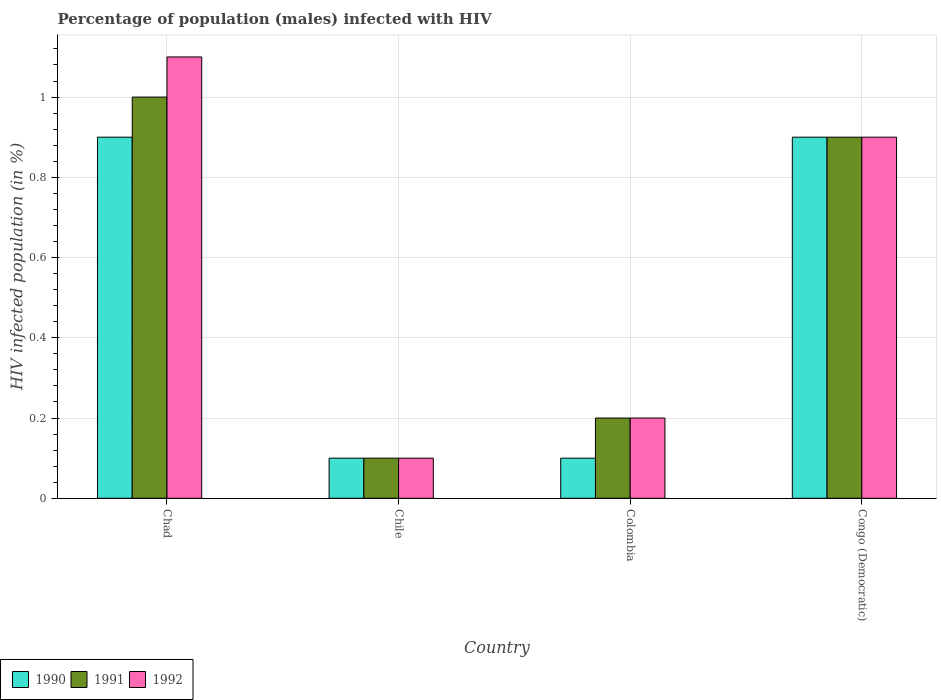What is the label of the 4th group of bars from the left?
Your answer should be very brief. Congo (Democratic). In how many cases, is the number of bars for a given country not equal to the number of legend labels?
Ensure brevity in your answer.  0. What is the percentage of HIV infected male population in 1992 in Chad?
Provide a short and direct response. 1.1. Across all countries, what is the minimum percentage of HIV infected male population in 1992?
Give a very brief answer. 0.1. In which country was the percentage of HIV infected male population in 1990 maximum?
Keep it short and to the point. Chad. What is the total percentage of HIV infected male population in 1990 in the graph?
Give a very brief answer. 2. What is the difference between the percentage of HIV infected male population in 1991 in Chad and that in Congo (Democratic)?
Your response must be concise. 0.1. What is the difference between the percentage of HIV infected male population in 1992 in Colombia and the percentage of HIV infected male population in 1991 in Chile?
Make the answer very short. 0.1. What is the average percentage of HIV infected male population in 1992 per country?
Give a very brief answer. 0.58. What is the ratio of the percentage of HIV infected male population in 1990 in Colombia to that in Congo (Democratic)?
Offer a very short reply. 0.11. What is the difference between the highest and the second highest percentage of HIV infected male population in 1992?
Offer a very short reply. -0.2. What does the 2nd bar from the left in Congo (Democratic) represents?
Offer a terse response. 1991. What does the 2nd bar from the right in Congo (Democratic) represents?
Offer a very short reply. 1991. How many bars are there?
Provide a short and direct response. 12. How many countries are there in the graph?
Provide a short and direct response. 4. Does the graph contain grids?
Your answer should be compact. Yes. How many legend labels are there?
Give a very brief answer. 3. What is the title of the graph?
Your answer should be very brief. Percentage of population (males) infected with HIV. Does "2000" appear as one of the legend labels in the graph?
Your answer should be compact. No. What is the label or title of the Y-axis?
Offer a very short reply. HIV infected population (in %). What is the HIV infected population (in %) of 1990 in Chad?
Give a very brief answer. 0.9. What is the HIV infected population (in %) in 1991 in Chad?
Keep it short and to the point. 1. What is the HIV infected population (in %) of 1992 in Chad?
Keep it short and to the point. 1.1. What is the HIV infected population (in %) of 1991 in Chile?
Provide a succinct answer. 0.1. What is the HIV infected population (in %) in 1991 in Colombia?
Provide a short and direct response. 0.2. What is the HIV infected population (in %) of 1990 in Congo (Democratic)?
Your answer should be very brief. 0.9. What is the HIV infected population (in %) of 1992 in Congo (Democratic)?
Offer a terse response. 0.9. Across all countries, what is the maximum HIV infected population (in %) in 1990?
Ensure brevity in your answer.  0.9. Across all countries, what is the maximum HIV infected population (in %) of 1991?
Provide a short and direct response. 1. Across all countries, what is the maximum HIV infected population (in %) of 1992?
Offer a very short reply. 1.1. Across all countries, what is the minimum HIV infected population (in %) of 1990?
Your answer should be very brief. 0.1. Across all countries, what is the minimum HIV infected population (in %) in 1991?
Your answer should be compact. 0.1. Across all countries, what is the minimum HIV infected population (in %) in 1992?
Ensure brevity in your answer.  0.1. What is the total HIV infected population (in %) of 1990 in the graph?
Ensure brevity in your answer.  2. What is the total HIV infected population (in %) in 1991 in the graph?
Offer a very short reply. 2.2. What is the total HIV infected population (in %) of 1992 in the graph?
Your answer should be very brief. 2.3. What is the difference between the HIV infected population (in %) in 1991 in Chad and that in Chile?
Offer a very short reply. 0.9. What is the difference between the HIV infected population (in %) of 1992 in Chad and that in Chile?
Ensure brevity in your answer.  1. What is the difference between the HIV infected population (in %) of 1990 in Chad and that in Colombia?
Give a very brief answer. 0.8. What is the difference between the HIV infected population (in %) in 1991 in Chad and that in Colombia?
Your response must be concise. 0.8. What is the difference between the HIV infected population (in %) of 1992 in Chad and that in Colombia?
Make the answer very short. 0.9. What is the difference between the HIV infected population (in %) in 1991 in Chad and that in Congo (Democratic)?
Ensure brevity in your answer.  0.1. What is the difference between the HIV infected population (in %) of 1992 in Chad and that in Congo (Democratic)?
Offer a terse response. 0.2. What is the difference between the HIV infected population (in %) in 1990 in Chile and that in Colombia?
Give a very brief answer. 0. What is the difference between the HIV infected population (in %) in 1991 in Chile and that in Colombia?
Provide a succinct answer. -0.1. What is the difference between the HIV infected population (in %) in 1990 in Chile and that in Congo (Democratic)?
Offer a terse response. -0.8. What is the difference between the HIV infected population (in %) in 1991 in Chile and that in Congo (Democratic)?
Your response must be concise. -0.8. What is the difference between the HIV infected population (in %) in 1990 in Chad and the HIV infected population (in %) in 1991 in Chile?
Your answer should be compact. 0.8. What is the difference between the HIV infected population (in %) of 1990 in Chad and the HIV infected population (in %) of 1992 in Chile?
Keep it short and to the point. 0.8. What is the difference between the HIV infected population (in %) of 1991 in Chad and the HIV infected population (in %) of 1992 in Chile?
Offer a terse response. 0.9. What is the difference between the HIV infected population (in %) of 1990 in Chad and the HIV infected population (in %) of 1991 in Colombia?
Offer a very short reply. 0.7. What is the difference between the HIV infected population (in %) of 1991 in Chad and the HIV infected population (in %) of 1992 in Colombia?
Your answer should be very brief. 0.8. What is the difference between the HIV infected population (in %) of 1991 in Chad and the HIV infected population (in %) of 1992 in Congo (Democratic)?
Your response must be concise. 0.1. What is the difference between the HIV infected population (in %) in 1990 in Chile and the HIV infected population (in %) in 1991 in Colombia?
Provide a short and direct response. -0.1. What is the difference between the HIV infected population (in %) in 1990 in Chile and the HIV infected population (in %) in 1992 in Congo (Democratic)?
Your answer should be compact. -0.8. What is the difference between the HIV infected population (in %) of 1990 in Colombia and the HIV infected population (in %) of 1991 in Congo (Democratic)?
Keep it short and to the point. -0.8. What is the difference between the HIV infected population (in %) of 1990 in Colombia and the HIV infected population (in %) of 1992 in Congo (Democratic)?
Ensure brevity in your answer.  -0.8. What is the difference between the HIV infected population (in %) in 1991 in Colombia and the HIV infected population (in %) in 1992 in Congo (Democratic)?
Make the answer very short. -0.7. What is the average HIV infected population (in %) in 1991 per country?
Offer a very short reply. 0.55. What is the average HIV infected population (in %) of 1992 per country?
Ensure brevity in your answer.  0.57. What is the difference between the HIV infected population (in %) of 1990 and HIV infected population (in %) of 1991 in Chad?
Make the answer very short. -0.1. What is the difference between the HIV infected population (in %) in 1991 and HIV infected population (in %) in 1992 in Chad?
Provide a short and direct response. -0.1. What is the difference between the HIV infected population (in %) in 1990 and HIV infected population (in %) in 1992 in Chile?
Your response must be concise. 0. What is the difference between the HIV infected population (in %) of 1991 and HIV infected population (in %) of 1992 in Chile?
Keep it short and to the point. 0. What is the difference between the HIV infected population (in %) of 1990 and HIV infected population (in %) of 1991 in Colombia?
Provide a short and direct response. -0.1. What is the difference between the HIV infected population (in %) in 1990 and HIV infected population (in %) in 1992 in Colombia?
Give a very brief answer. -0.1. What is the difference between the HIV infected population (in %) of 1991 and HIV infected population (in %) of 1992 in Colombia?
Keep it short and to the point. 0. What is the difference between the HIV infected population (in %) in 1990 and HIV infected population (in %) in 1992 in Congo (Democratic)?
Give a very brief answer. 0. What is the ratio of the HIV infected population (in %) in 1992 in Chad to that in Chile?
Your answer should be compact. 11. What is the ratio of the HIV infected population (in %) in 1990 in Chad to that in Colombia?
Your answer should be compact. 9. What is the ratio of the HIV infected population (in %) in 1992 in Chad to that in Colombia?
Offer a terse response. 5.5. What is the ratio of the HIV infected population (in %) of 1990 in Chad to that in Congo (Democratic)?
Your answer should be very brief. 1. What is the ratio of the HIV infected population (in %) in 1992 in Chad to that in Congo (Democratic)?
Make the answer very short. 1.22. What is the ratio of the HIV infected population (in %) of 1991 in Chile to that in Colombia?
Your answer should be very brief. 0.5. What is the ratio of the HIV infected population (in %) in 1991 in Chile to that in Congo (Democratic)?
Provide a short and direct response. 0.11. What is the ratio of the HIV infected population (in %) in 1991 in Colombia to that in Congo (Democratic)?
Your answer should be very brief. 0.22. What is the ratio of the HIV infected population (in %) in 1992 in Colombia to that in Congo (Democratic)?
Provide a succinct answer. 0.22. What is the difference between the highest and the second highest HIV infected population (in %) in 1992?
Provide a succinct answer. 0.2. What is the difference between the highest and the lowest HIV infected population (in %) in 1991?
Provide a succinct answer. 0.9. 